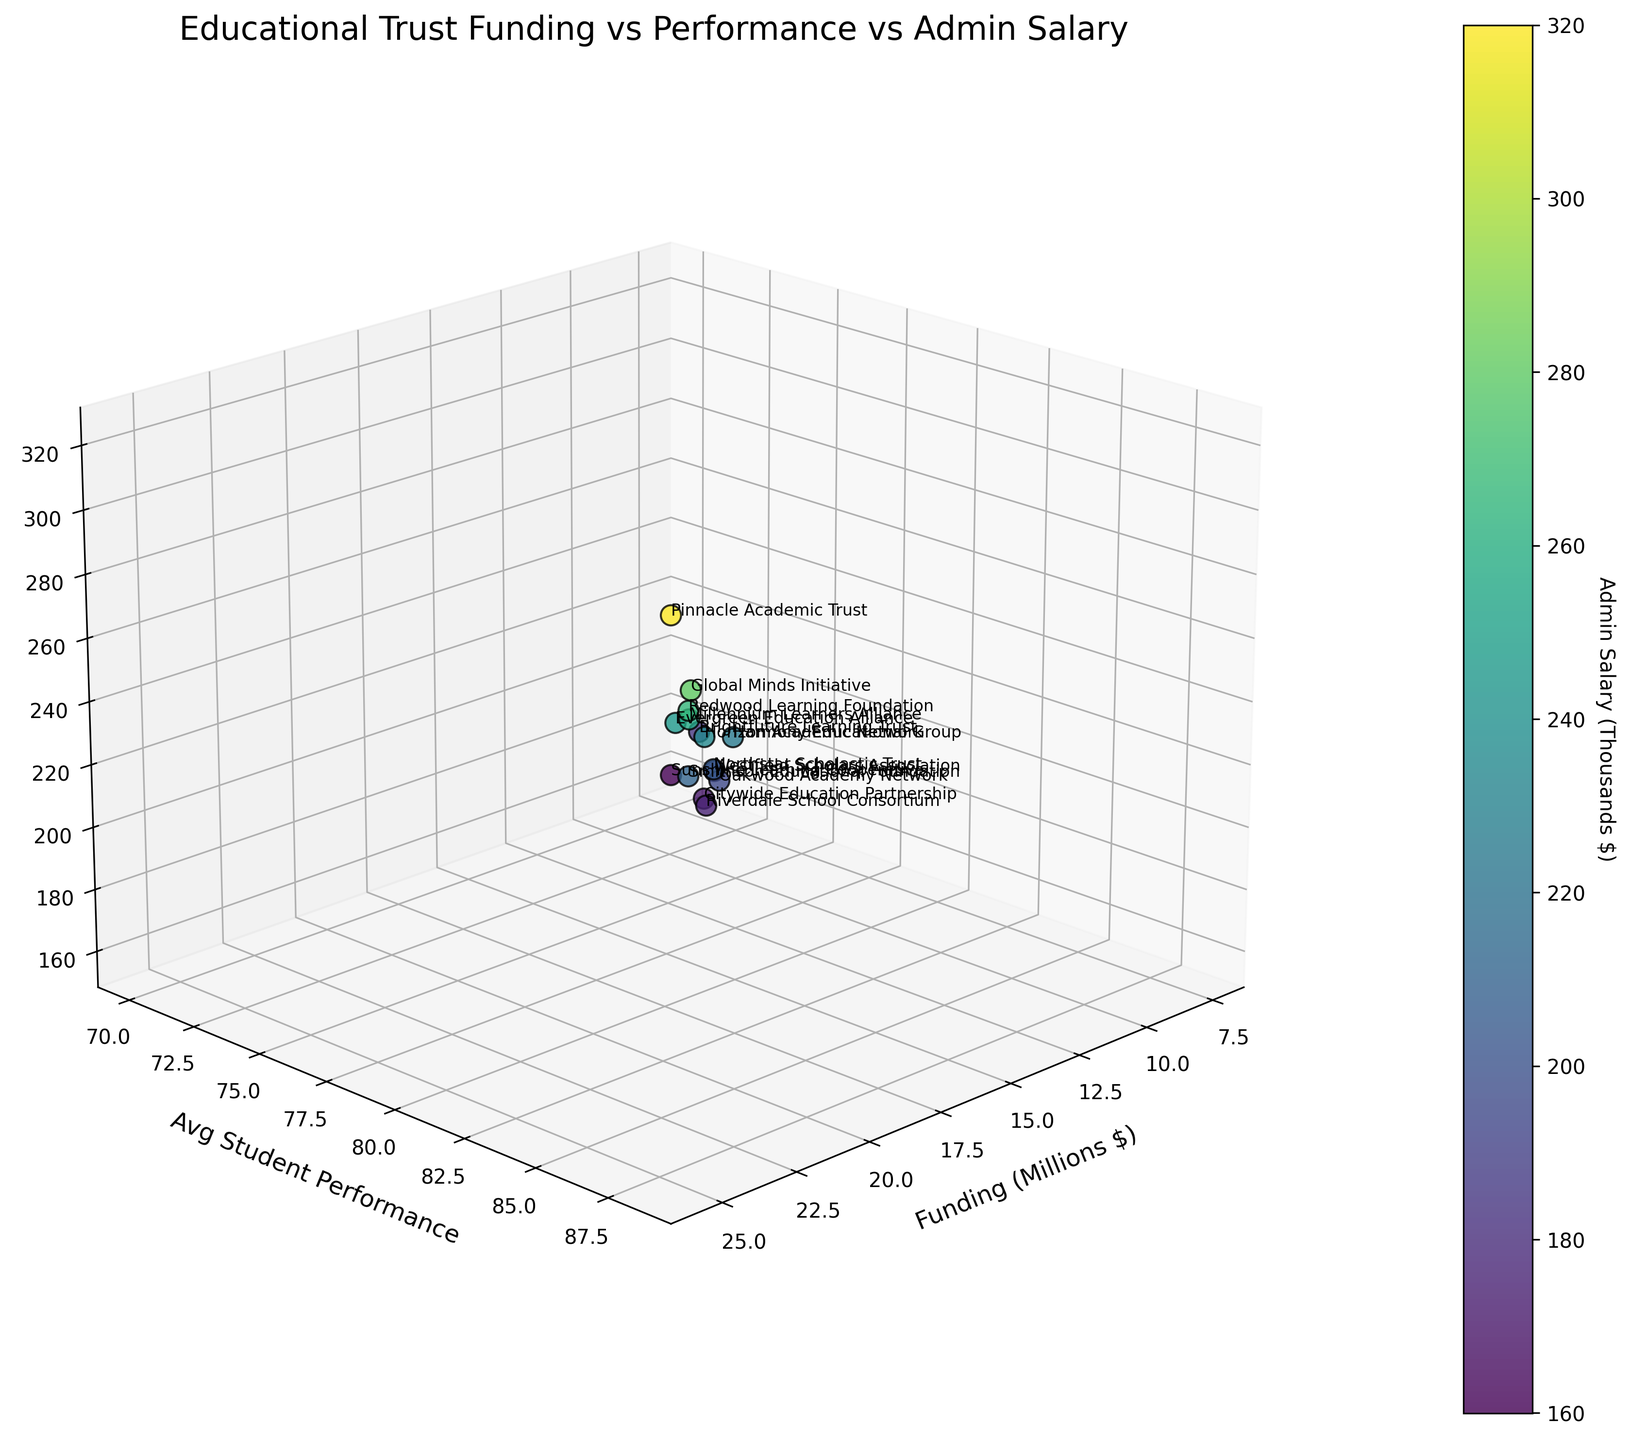what is the title of this chart? The title is indicated at the top of the chart. It provides an overview of what the chart represents.
Answer: Educational Trust Funding vs Performance vs Admin Salary Which trust has the highest funding? Locate the point farthest to the right on the Funding (Millions $) axis. Find the associated trust name.
Answer: Pinnacle Academic Trust How is the color of the points determined? The color represents the Admin Salary (Thousands $), as indicated by the color bar to the right.
Answer: Based on Admin Salary What is the average student performance for Evergreen Education Alliance? Find the data point labeled with the trust name and read off the Avg Student Performance value.
Answer: 81.2 How does Global Minds Initiative's average student performance compare to Millennium Learners Alliance? Identify the points for both trusts and compare the Avg Student Performance values.
Answer: Global Minds Initiative: 85.6, Millennium Learners Alliance: 82.9 Which trust has the lowest administrative salary, and what is that salary? The administrative salaries are represented by the color gradient. Locate the darkest point (fewest thousands) associated with the trust name.
Answer: Sunshine Learning Cooperative, 160 List the trusts with average student performances above 80. Identify all points where Avg Student Performance is greater than 80, then list the corresponding trust names.
Answer: Global Minds Initiative, Evergreen Education Alliance, Redwood Learning Foundation, Horizon Academic Network, Millennium Learners Alliance, Pinnacle Academic Trust Does higher funding correlate with higher average student performance? Observe the general trend of points relative to the Funding and Avg Student Performance axes.
Answer: There's no clear correlation Which trust has both high funding and high administrative salaries? Identify points with both high values on the Funding and Admin Salary axes, and check which trust names are associated.
Answer: Pinnacle Academic Trust Considering Riverdale School Consortium and Oakwood Academy Network, which has a higher average student performance and by how much? Find the values for both trusts and subtract one from the other to find the difference.
Answer: Oakwood Academy Network by 2.1 